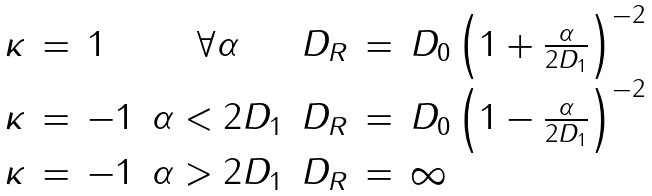<formula> <loc_0><loc_0><loc_500><loc_500>\begin{array} { r c l c r c l } \kappa & = & 1 & \forall \alpha & D _ { R } & = & D _ { 0 } \left ( 1 + \frac { \alpha } { 2 D _ { 1 } } \right ) ^ { - 2 } \\ \kappa & = & - 1 & \alpha < 2 D _ { 1 } & D _ { R } & = & D _ { 0 } \left ( 1 - \frac { \alpha } { 2 D _ { 1 } } \right ) ^ { - 2 } \\ \kappa & = & - 1 & \alpha > 2 D _ { 1 } & D _ { R } & = & \infty \end{array}</formula> 